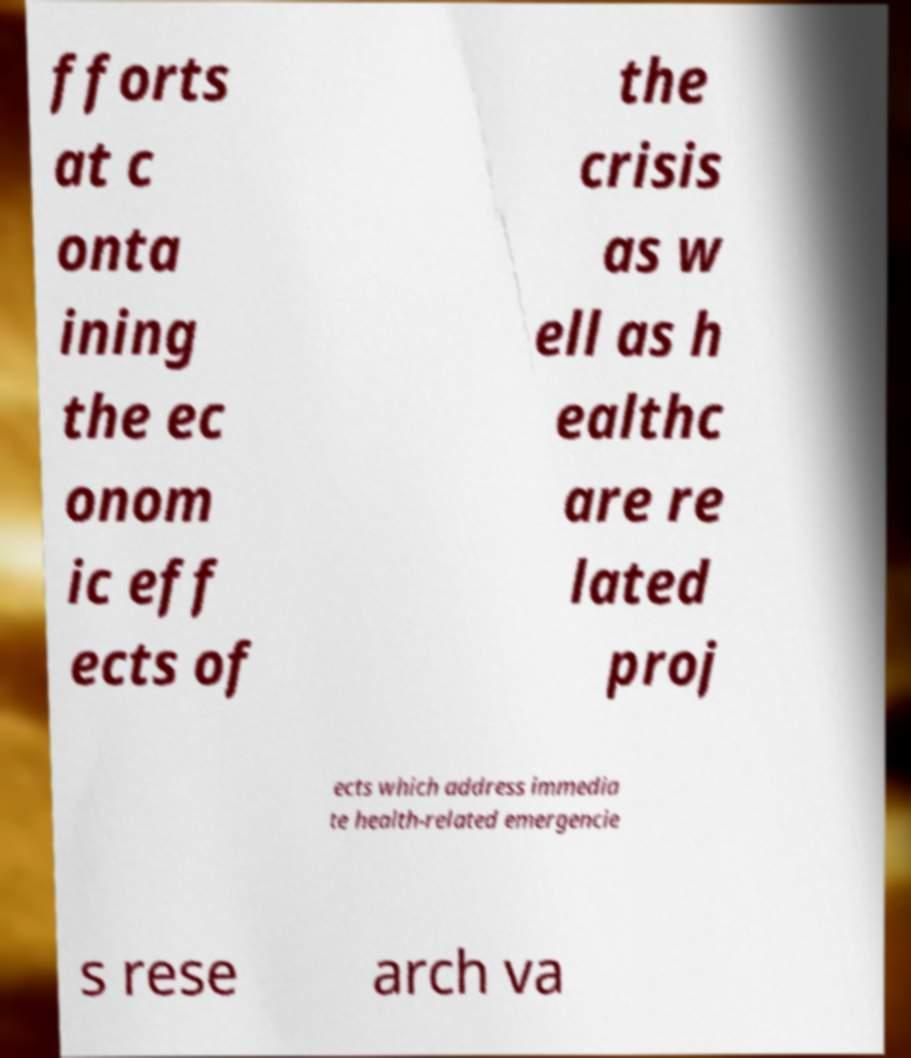Could you extract and type out the text from this image? fforts at c onta ining the ec onom ic eff ects of the crisis as w ell as h ealthc are re lated proj ects which address immedia te health-related emergencie s rese arch va 